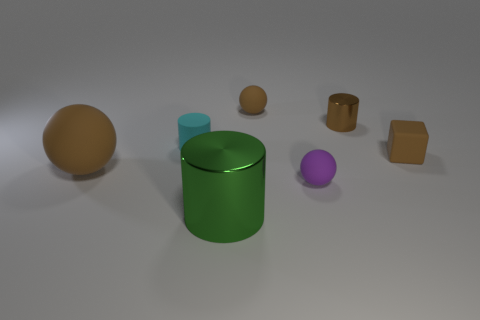Add 1 small brown cylinders. How many objects exist? 8 Subtract all blocks. How many objects are left? 6 Add 3 matte objects. How many matte objects exist? 8 Subtract 0 cyan balls. How many objects are left? 7 Subtract all small green matte things. Subtract all metal cylinders. How many objects are left? 5 Add 3 metallic things. How many metallic things are left? 5 